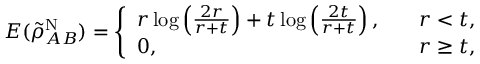<formula> <loc_0><loc_0><loc_500><loc_500>\begin{array} { r } { E ( \tilde { \rho } _ { A B } ^ { N } ) = \left \{ \begin{array} { l l } { r \log \left ( \frac { 2 r } { r + t } \right ) + t \log \left ( \frac { 2 t } { r + t } \right ) , \quad } & { r < t , } \\ { 0 , \quad } & { r \geq t , } \end{array} } \end{array}</formula> 